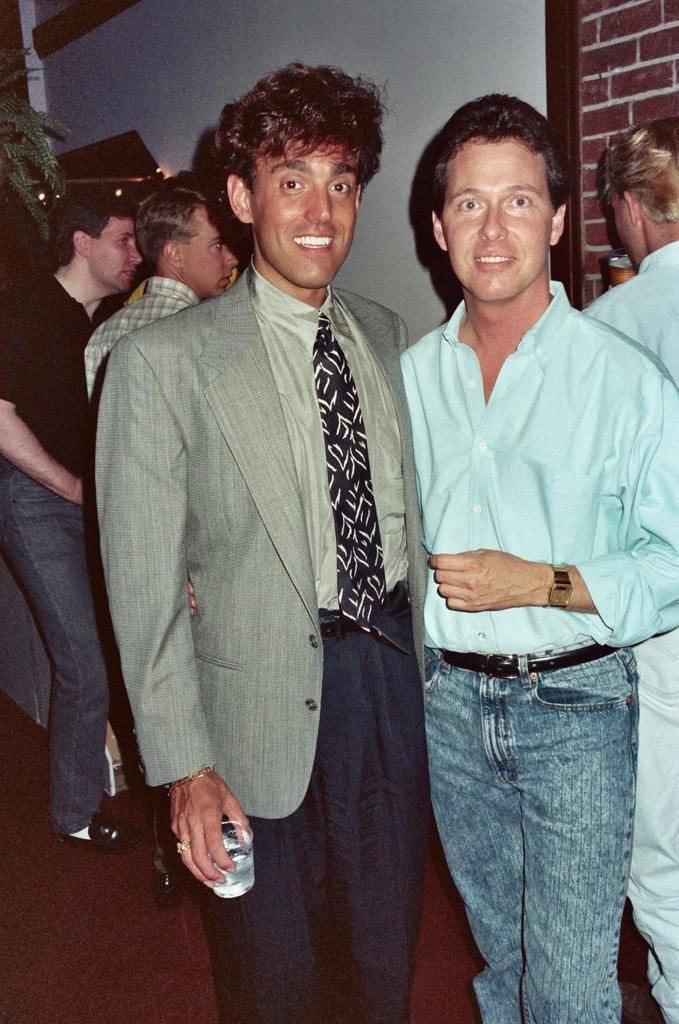How many people are in the image? There are people in the image, but the exact number is not specified. What is one person holding in the image? One person is holding a glass in the image. What is the other person doing in the image? The other person is drinking in the image. What type of vegetation can be seen in the image? There is a plant in the image. What type of structure is visible in the image? There is a wall in the image. What type of floor can be seen in the image? The facts provided do not mention the floor, so it is not possible to determine the type of floor in the image. 